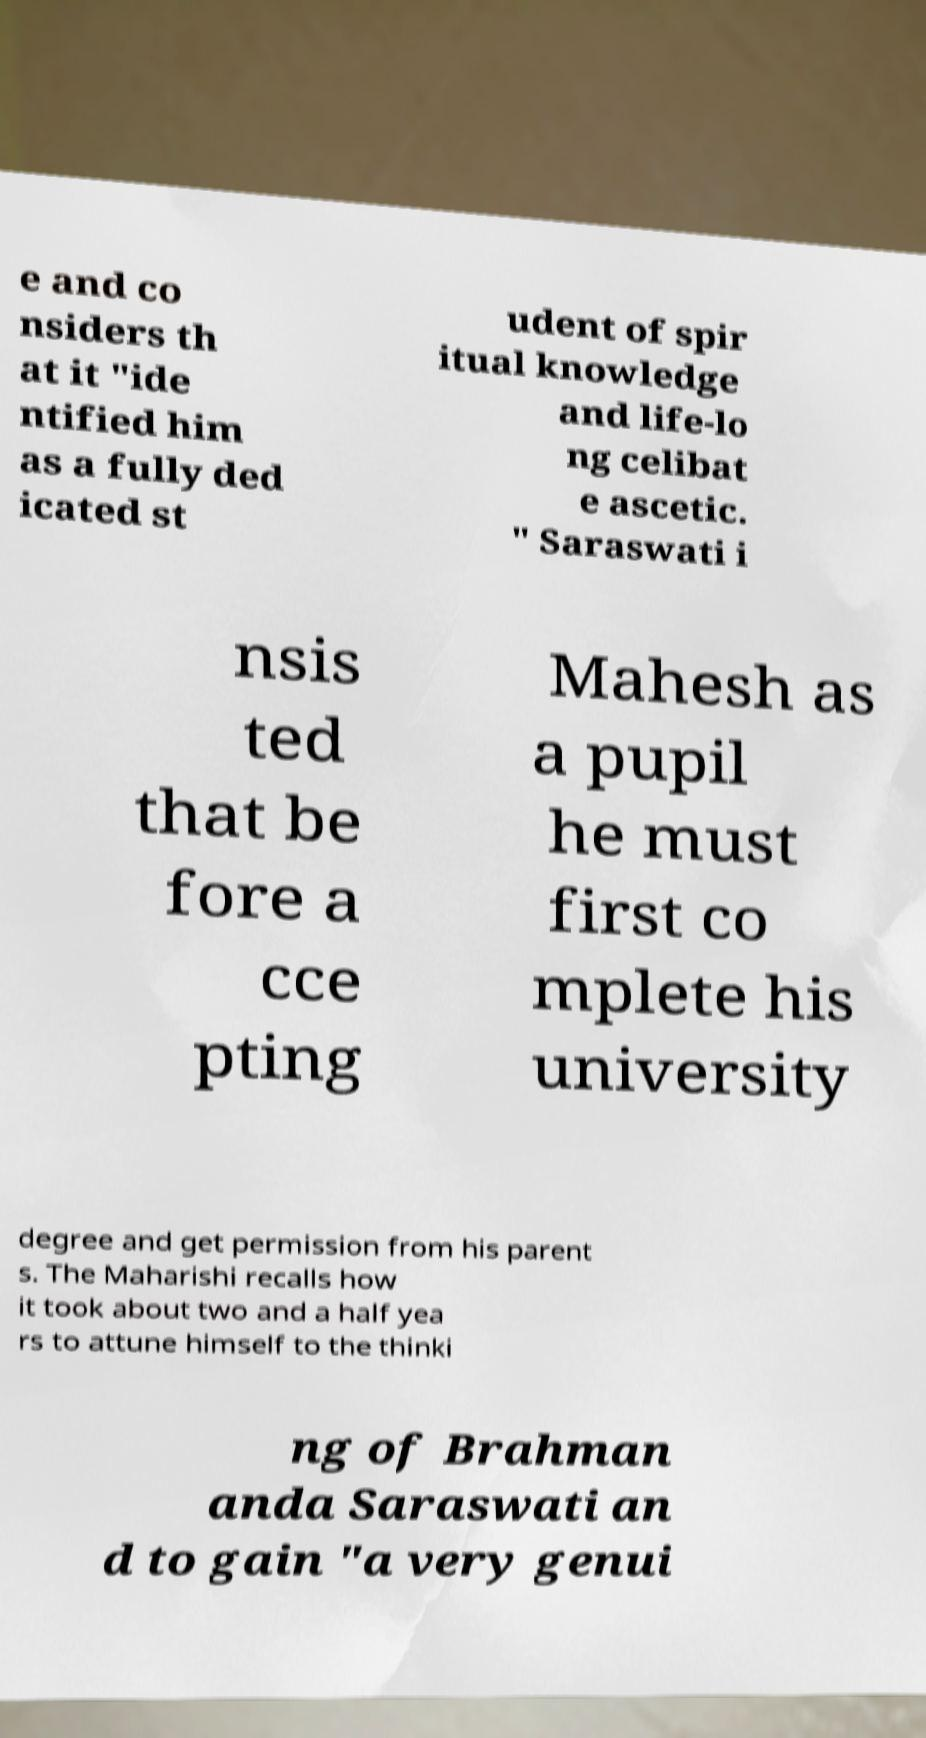Please read and relay the text visible in this image. What does it say? e and co nsiders th at it "ide ntified him as a fully ded icated st udent of spir itual knowledge and life-lo ng celibat e ascetic. " Saraswati i nsis ted that be fore a cce pting Mahesh as a pupil he must first co mplete his university degree and get permission from his parent s. The Maharishi recalls how it took about two and a half yea rs to attune himself to the thinki ng of Brahman anda Saraswati an d to gain "a very genui 